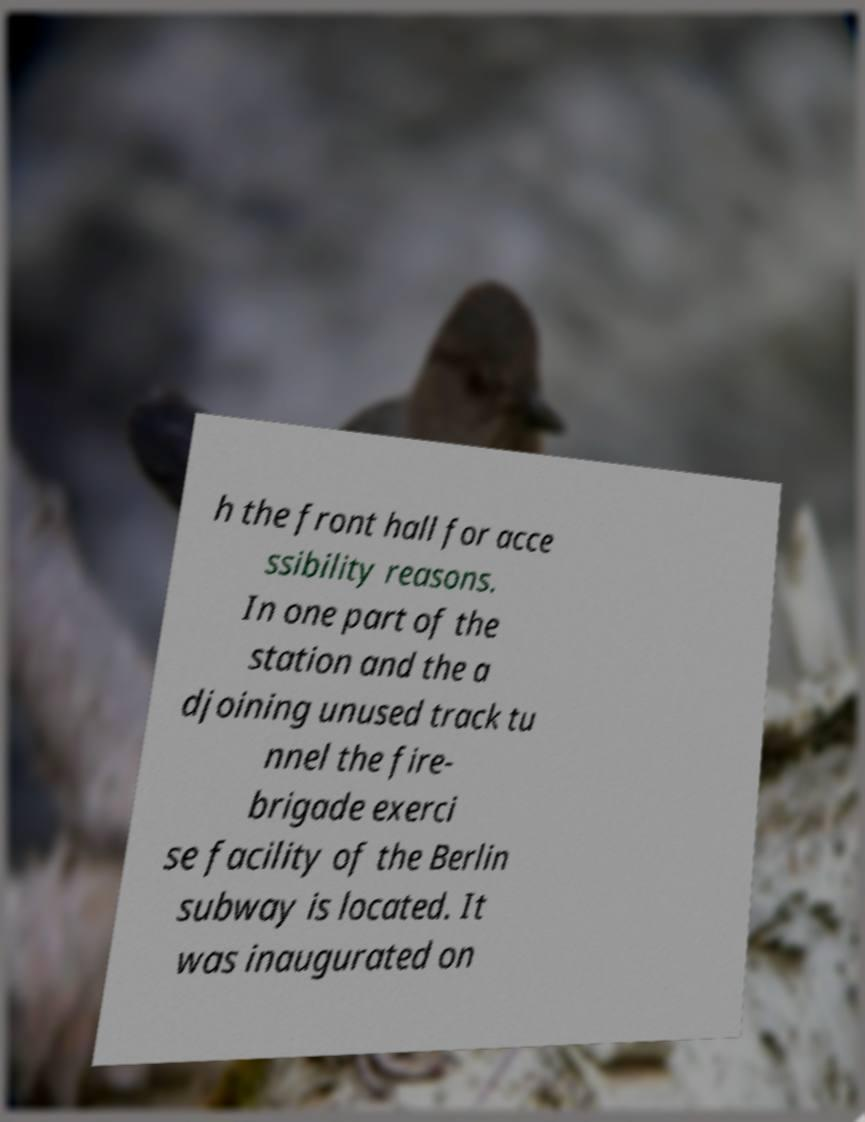Please read and relay the text visible in this image. What does it say? h the front hall for acce ssibility reasons. In one part of the station and the a djoining unused track tu nnel the fire- brigade exerci se facility of the Berlin subway is located. It was inaugurated on 